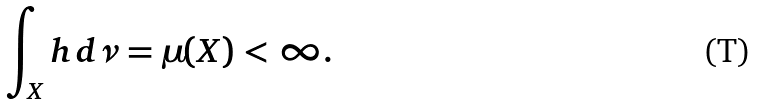Convert formula to latex. <formula><loc_0><loc_0><loc_500><loc_500>\int _ { X } h \, d \nu = \mu ( X ) < \infty .</formula> 